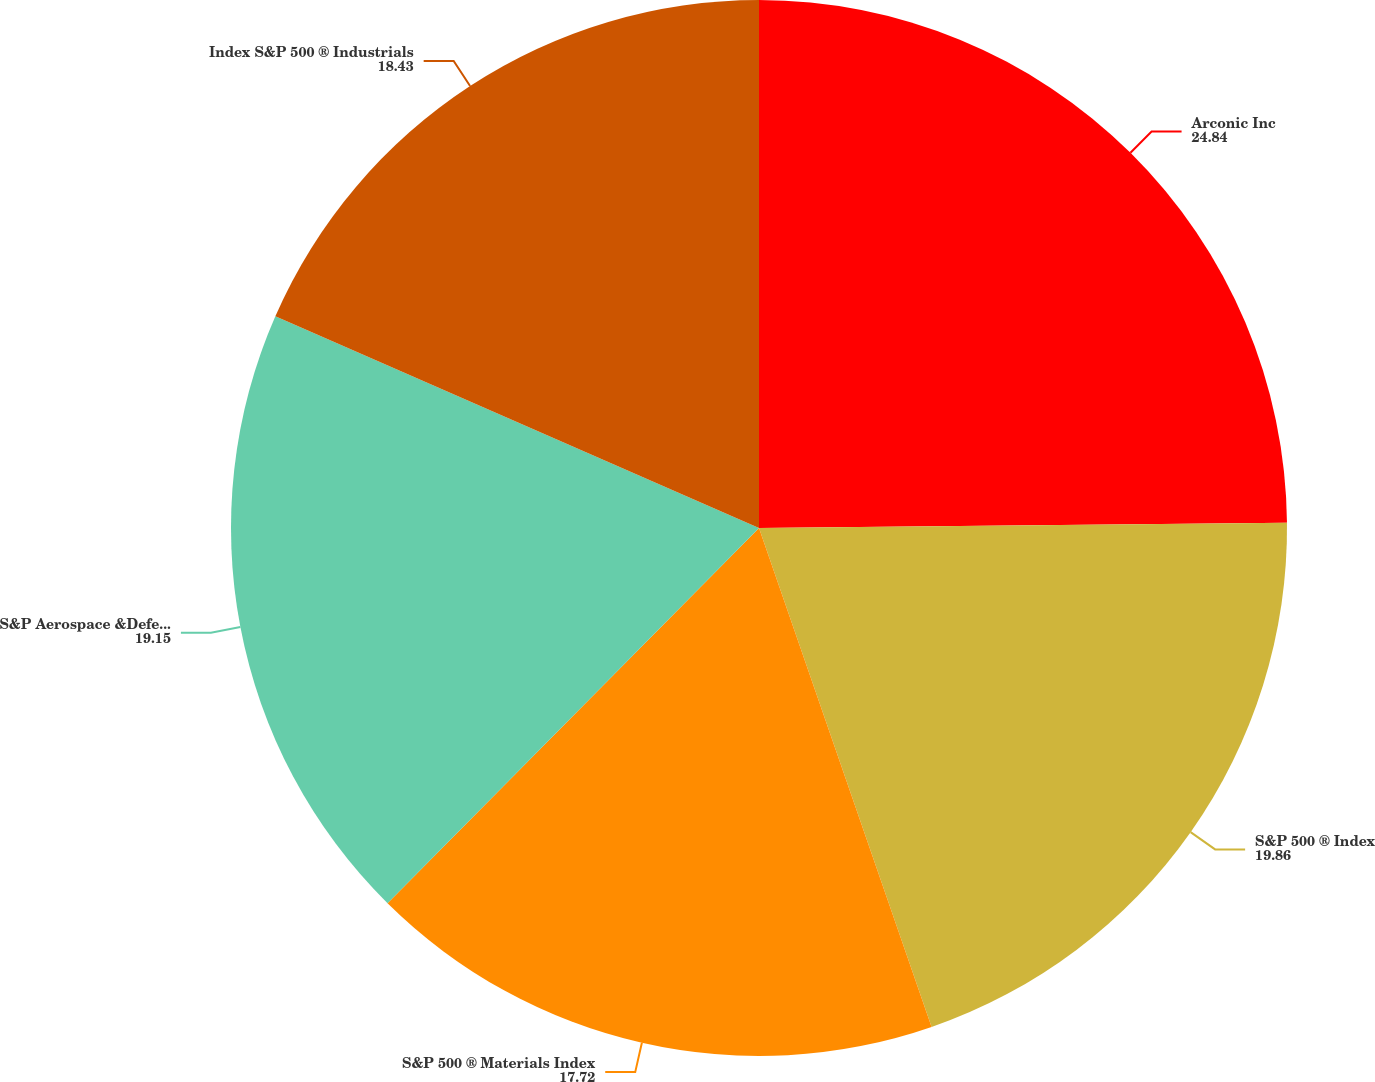Convert chart to OTSL. <chart><loc_0><loc_0><loc_500><loc_500><pie_chart><fcel>Arconic Inc<fcel>S&P 500 ® Index<fcel>S&P 500 ® Materials Index<fcel>S&P Aerospace &Defense Select<fcel>Index S&P 500 ® Industrials<nl><fcel>24.84%<fcel>19.86%<fcel>17.72%<fcel>19.15%<fcel>18.43%<nl></chart> 